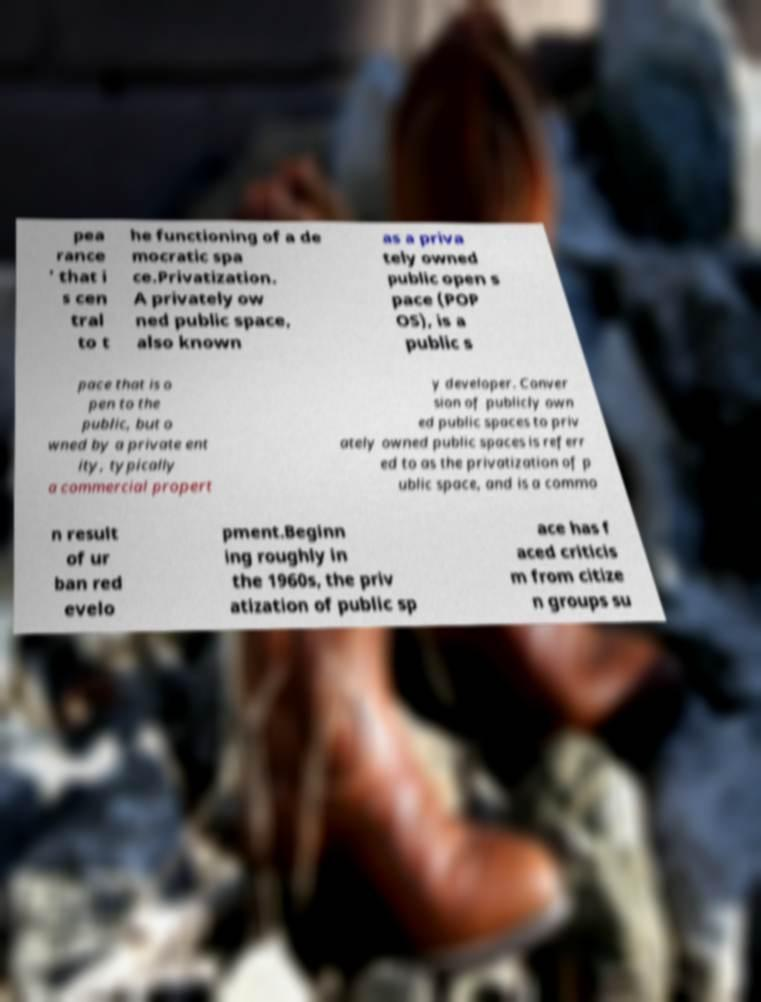What messages or text are displayed in this image? I need them in a readable, typed format. pea rance ' that i s cen tral to t he functioning of a de mocratic spa ce.Privatization. A privately ow ned public space, also known as a priva tely owned public open s pace (POP OS), is a public s pace that is o pen to the public, but o wned by a private ent ity, typically a commercial propert y developer. Conver sion of publicly own ed public spaces to priv ately owned public spaces is referr ed to as the privatization of p ublic space, and is a commo n result of ur ban red evelo pment.Beginn ing roughly in the 1960s, the priv atization of public sp ace has f aced criticis m from citize n groups su 